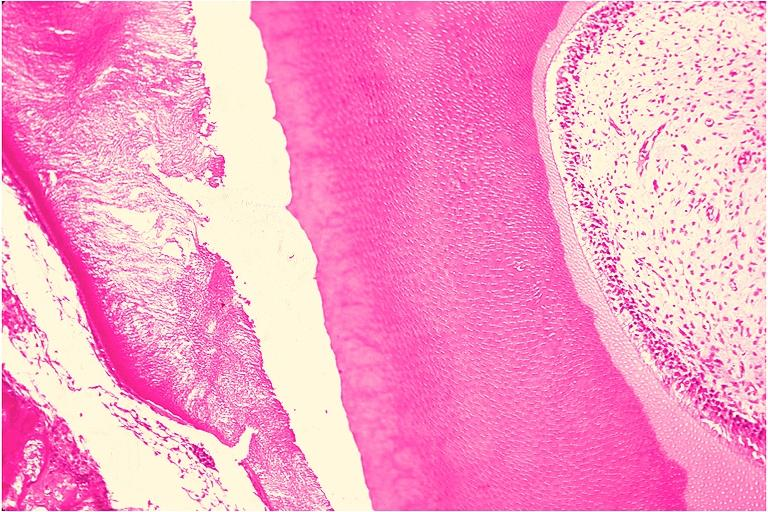what does this image show?
Answer the question using a single word or phrase. Odontoma 